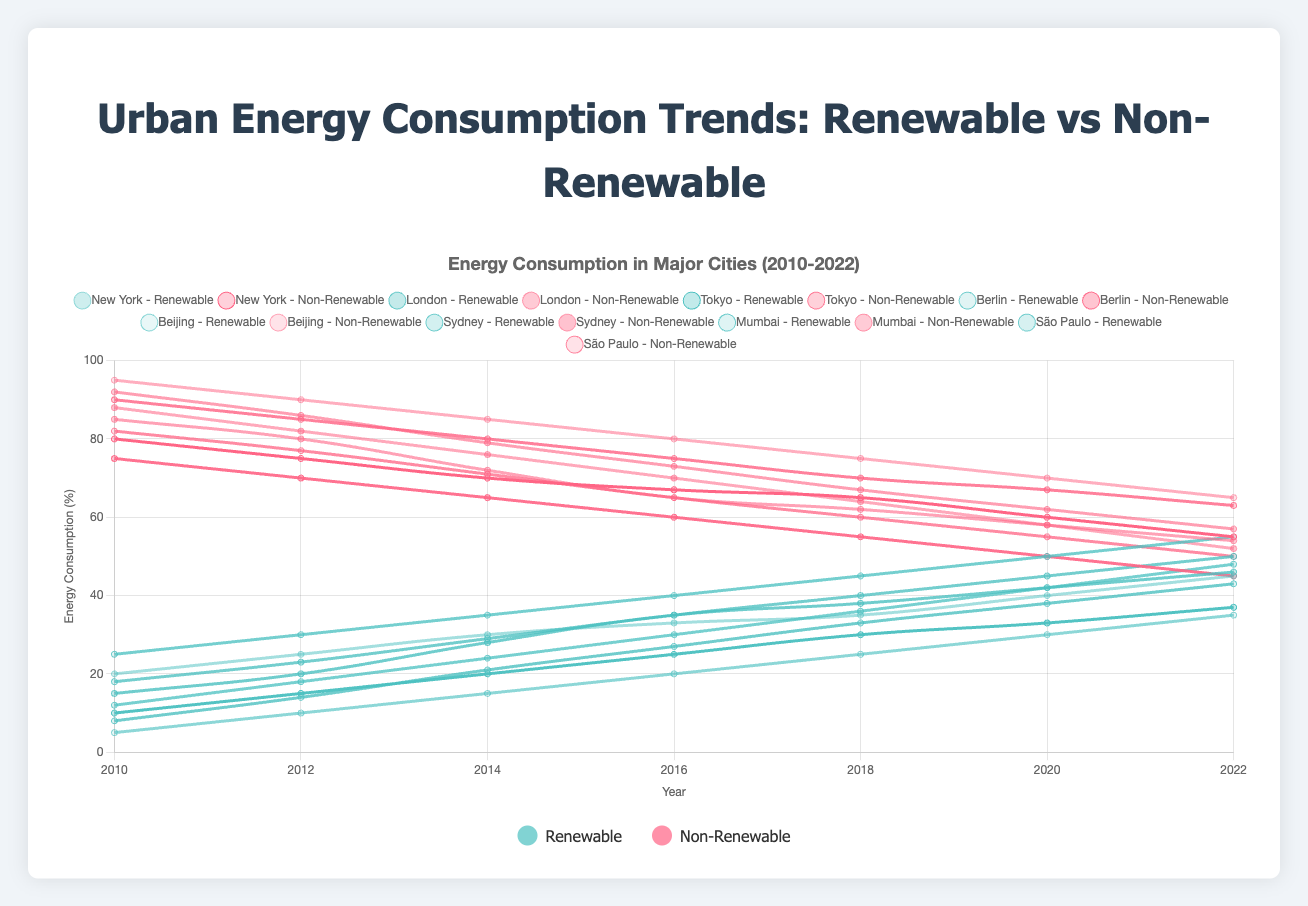What is the trend in renewable energy consumption in New York from 2010 to 2022? The renewable energy consumption in New York shows a consistent increasing trend over the years. In 2010 it was 20%, and by 2022 it reached 45%.
Answer: Increasing Which city shows the highest use of renewable energy in 2022? By examining the line plots for renewable energy in 2022, Berlin has the highest renewable energy consumption at 55%.
Answer: Berlin How does the non-renewable energy consumption trend in Tokyo compare to the trend in Paris from 2010 to 2022? From the plots, Tokyo's non-renewable energy consumption decreases from 90% in 2010 to 63% in 2022. Berlin's non-renewable energy consumption drops from 75% in 2010 to 45% in 2022. Both cities show a decline, but Berlin has a steeper decrease.
Answer: Both decline; Berlin steeper Which city had the lowest renewable energy consumption in 2010, and what was the corresponding percentage? In 2010, Beijing had the lowest renewable energy consumption at 5%.
Answer: Beijing, 5% By what percentage did renewable energy consumption in Sydney increase from 2010 to 2022? Renewable energy consumption in Sydney rose from 12% in 2010 to 48% in 2022. The change is 48% - 12% = 36%.
Answer: 36% What is the average percentage of non-renewable energy consumption in São Paulo over the years 2010, 2014, and 2018? The non-renewable consumption values for São Paulo are 82% (2010), 71% (2014), and 60% (2018). The average is (82 + 71 + 60) / 3 = 71%.
Answer: 71% In 2018, which city had a closer percentage of renewable to non-renewable energy consumption, and what were these percentages? In 2018, Berlin's renewable was 45% and non-renewable was 55%, which are closest compared to other cities.
Answer: Berlin, 45% renewable, 55% non-renewable By examining the trends, which city seems to be transitioning the fastest towards renewable energy from 2010 to 2022? Berlin shows the fastest transition with renewable energy rising from 25% in 2010 to 55% in 2022, a 30% increase.
Answer: Berlin Compared to New York, how much higher was Beijing's non-renewable energy consumption in 2016? In 2016, Beijing's non-renewable consumption was 80%, and New York's was 67%. The difference is 80% - 67% = 13%.
Answer: 13% What was the difference in renewable energy consumption between Mumbai and London in 2020? In 2020, Mumbai's renewable consumption was 38%, and London's was 42%. The difference is 42% - 38% = 4%.
Answer: 4% 